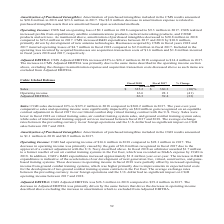According to Cubic's financial document, What is the percentage change in CGD sales in 2018? According to the financial document, decreased 10%. The relevant text states: "Adjusted EBITDA 26.3 39.4 (33) Sales: CGD sales decreased 10% to $325.2 million in 2018 compared to $360.2 million in 2017. The year-over-year comparative sales a..." Also, What is the increase in R&D expenditures indicative of? Based on the financial document, the answer is the acceleration of our development of next generation live, virtual, constructive, and game-based training systems. Also, For which years is the amortization of purchased intangibles included in the CGD results recorded? The document shows two values: 2018 and 2017. From the document: "ted to $20.8 million in 2018 and $23.6 million in 2017. The $2.8 million decrease in amortization expense is related to purchased intangible assets th..." Additionally, In which year is the amortization of purchased intangibles included in the CGD results larger? According to the financial document, 2018. The relevant text states: "d in the CMS results amounted to $20.8 million in 2018 and $23.6 million in 2017. The $2.8 million decrease in amortization expense is related to purchase..." Also, can you calculate: What is the change in operating income from 2017 to 2018? Based on the calculation: 16.6-28.1, the result is -11.5 (in millions). This is based on the information: "Sales $ 325.2 $ 360.2 (10)% Operating income 16.6 28.1 (41) Sales $ 325.2 $ 360.2 (10)% Operating income 16.6 28.1 (41)..." The key data points involved are: 16.6, 28.1. Also, can you calculate: What is the average adjusted EBITDA in 2017 and 2018? To answer this question, I need to perform calculations using the financial data. The calculation is: (26.3+39.4)/2, which equals 32.85 (in millions). This is based on the information: "Adjusted EBITDA 26.3 39.4 (33) Sales: CGD sales decreased 10% to $325.2 million in 2018 compared to $360.2 million in 20 Adjusted EBITDA 26.3 39.4 (33) Sales: CGD sales decreased 10% to $325.2 million..." The key data points involved are: 26.3, 39.4. 